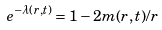Convert formula to latex. <formula><loc_0><loc_0><loc_500><loc_500>e ^ { - \lambda ( r , t ) } = 1 - 2 m ( r , t ) / r</formula> 